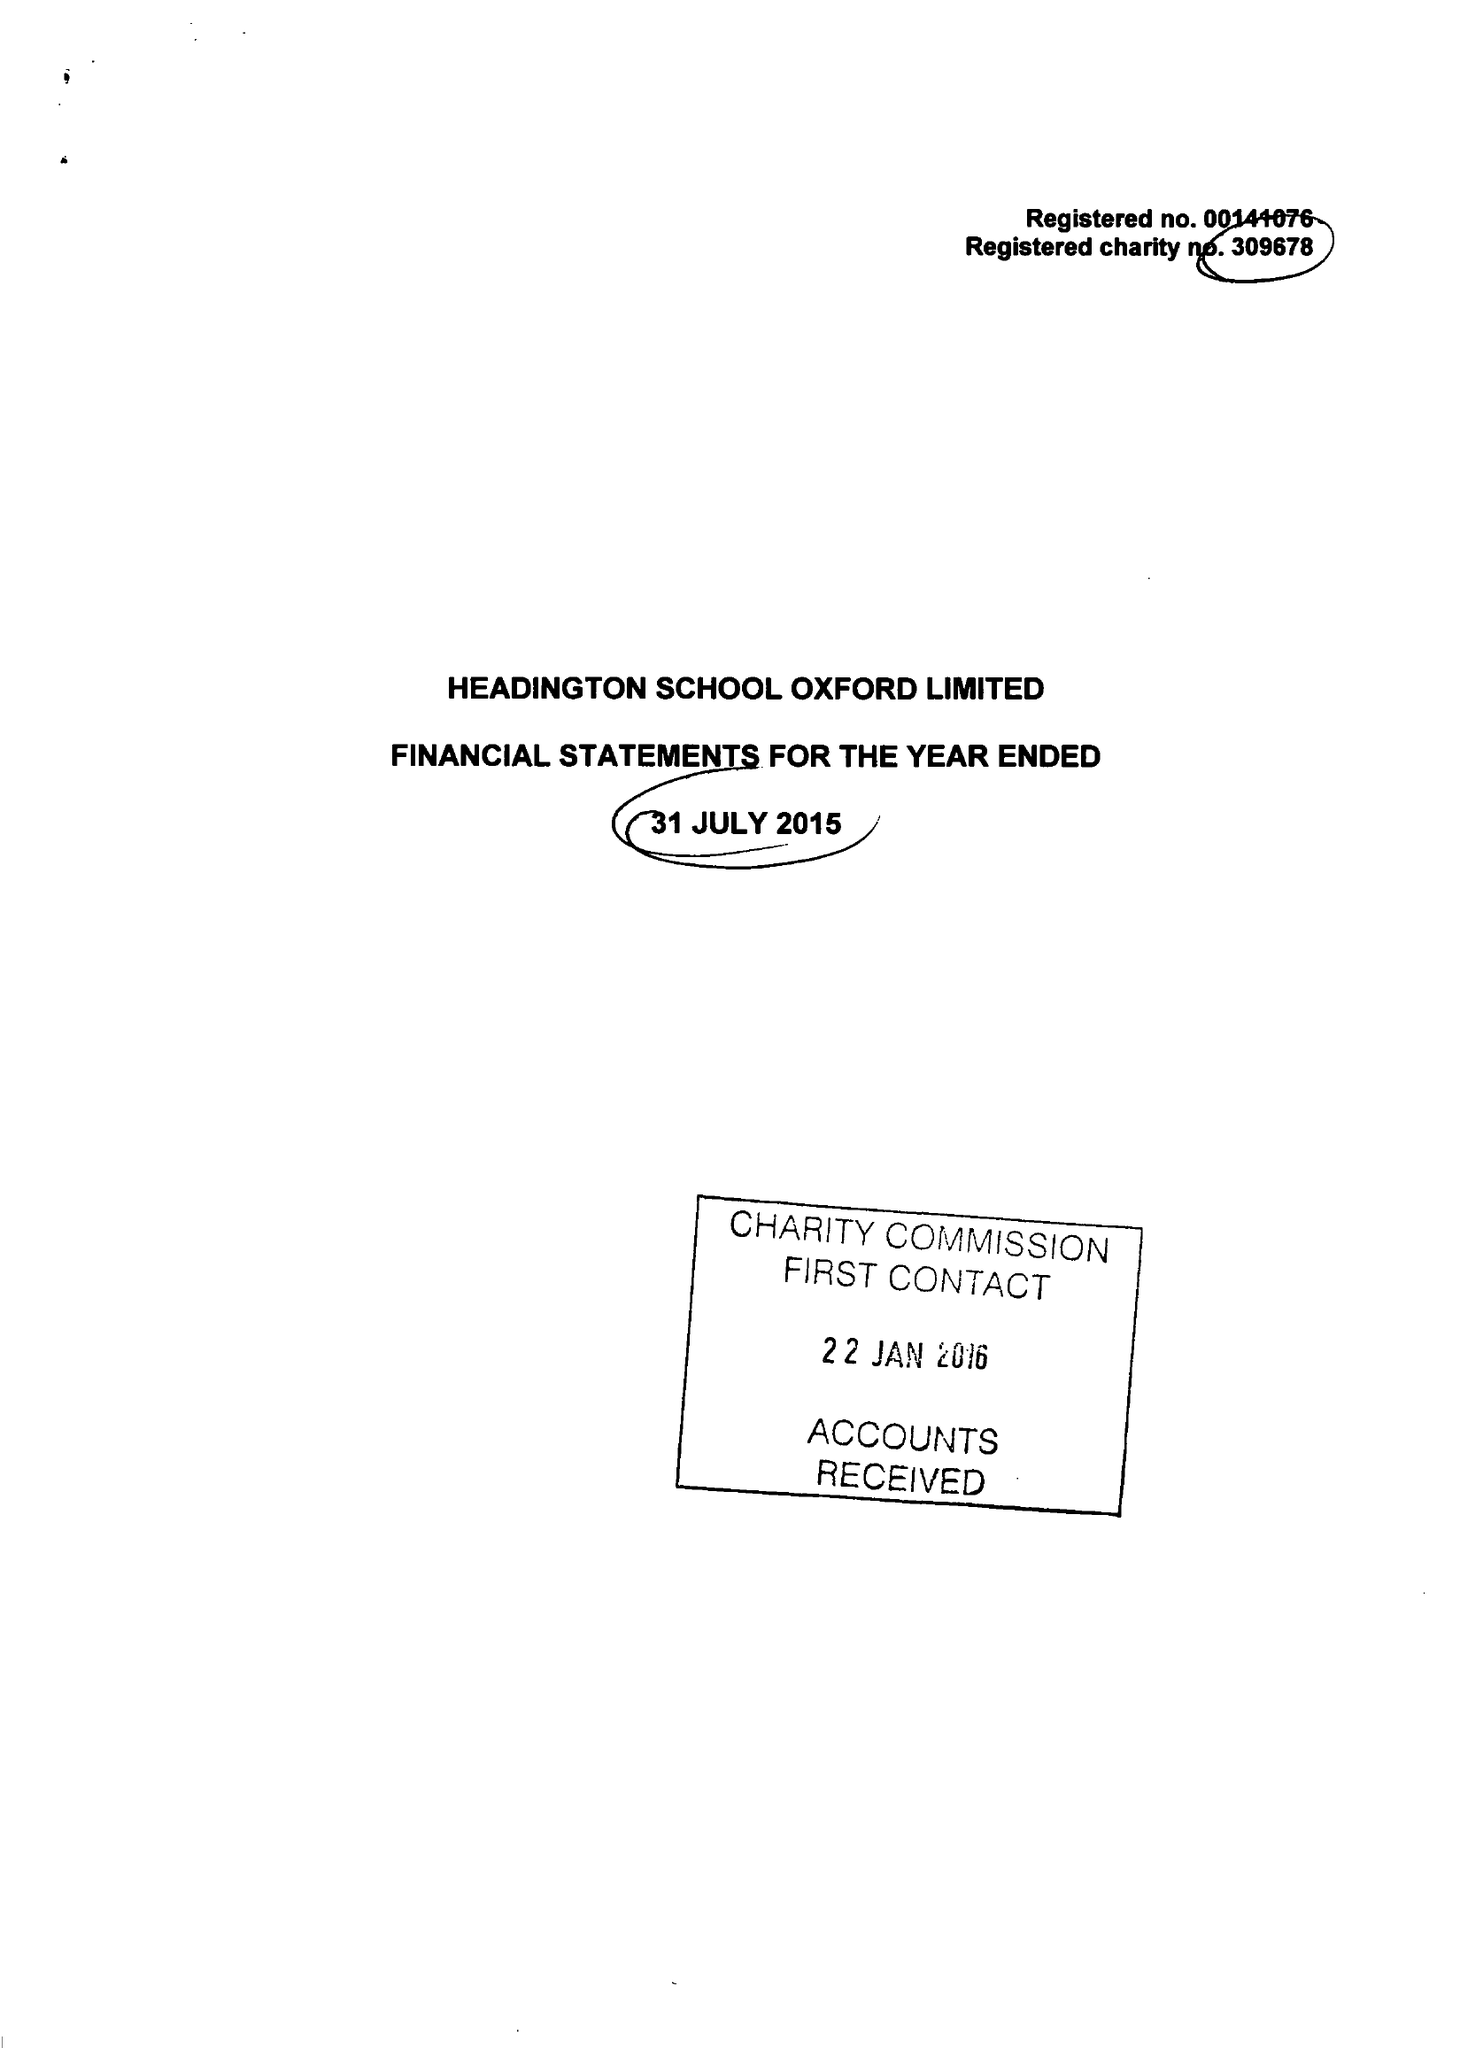What is the value for the charity_name?
Answer the question using a single word or phrase. Headington School Oxford Ltd. 